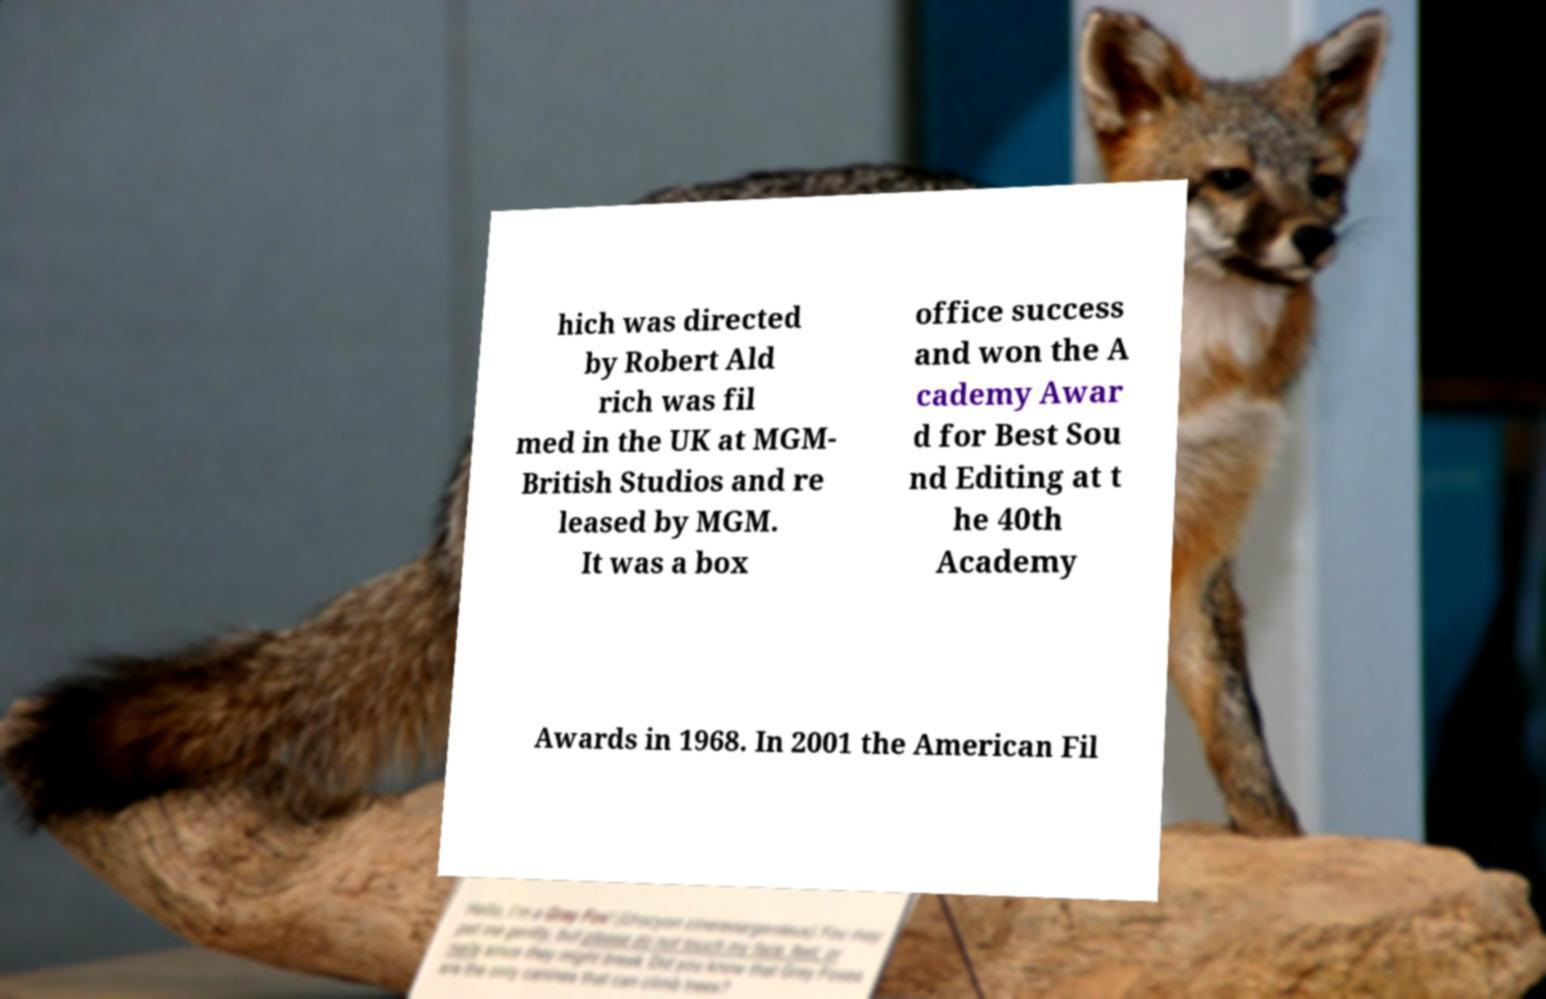There's text embedded in this image that I need extracted. Can you transcribe it verbatim? hich was directed by Robert Ald rich was fil med in the UK at MGM- British Studios and re leased by MGM. It was a box office success and won the A cademy Awar d for Best Sou nd Editing at t he 40th Academy Awards in 1968. In 2001 the American Fil 